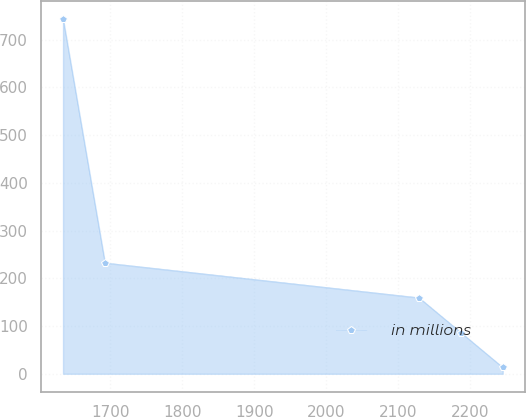<chart> <loc_0><loc_0><loc_500><loc_500><line_chart><ecel><fcel>in millions<nl><fcel>1634.1<fcel>743.44<nl><fcel>1692.28<fcel>232.44<nl><fcel>2128.57<fcel>159.44<nl><fcel>2186.75<fcel>86.44<nl><fcel>2244.93<fcel>13.44<nl></chart> 